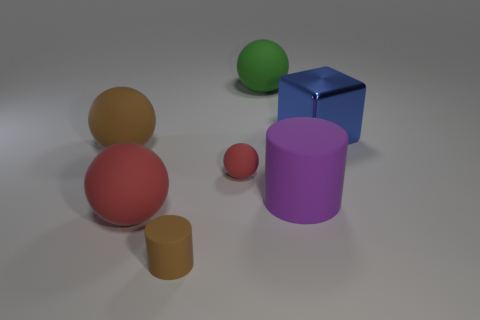Subtract all big red spheres. How many spheres are left? 3 Subtract all green cylinders. How many red balls are left? 2 Subtract all brown spheres. How many spheres are left? 3 Add 2 tiny red matte balls. How many objects exist? 9 Subtract all spheres. How many objects are left? 3 Subtract all blue balls. Subtract all cyan cubes. How many balls are left? 4 Add 7 brown things. How many brown things are left? 9 Add 2 small yellow cubes. How many small yellow cubes exist? 2 Subtract 0 gray cylinders. How many objects are left? 7 Subtract all large brown rubber spheres. Subtract all green matte spheres. How many objects are left? 5 